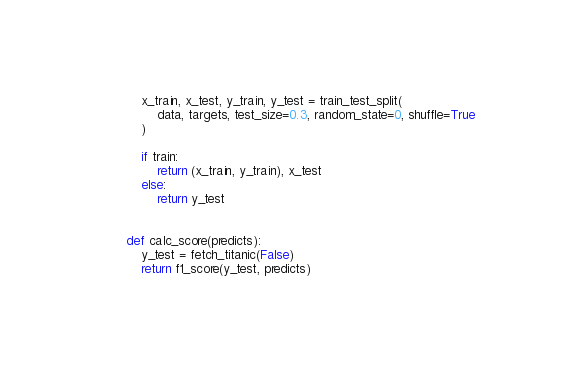<code> <loc_0><loc_0><loc_500><loc_500><_Python_>
    x_train, x_test, y_train, y_test = train_test_split(
        data, targets, test_size=0.3, random_state=0, shuffle=True
    )

    if train:
        return (x_train, y_train), x_test
    else:
        return y_test


def calc_score(predicts):
    y_test = fetch_titanic(False)
    return f1_score(y_test, predicts)
</code> 